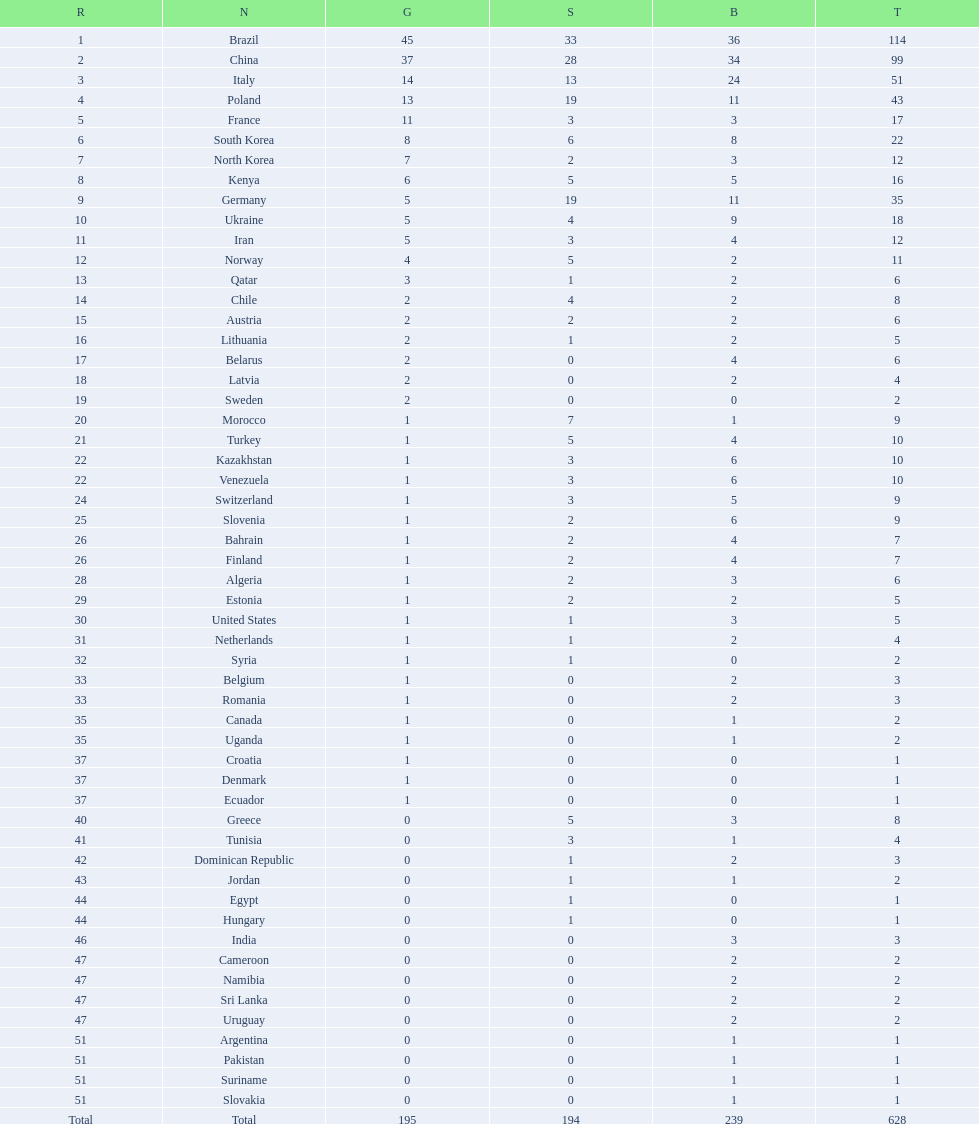Did italy or norway have 51 total medals? Italy. 